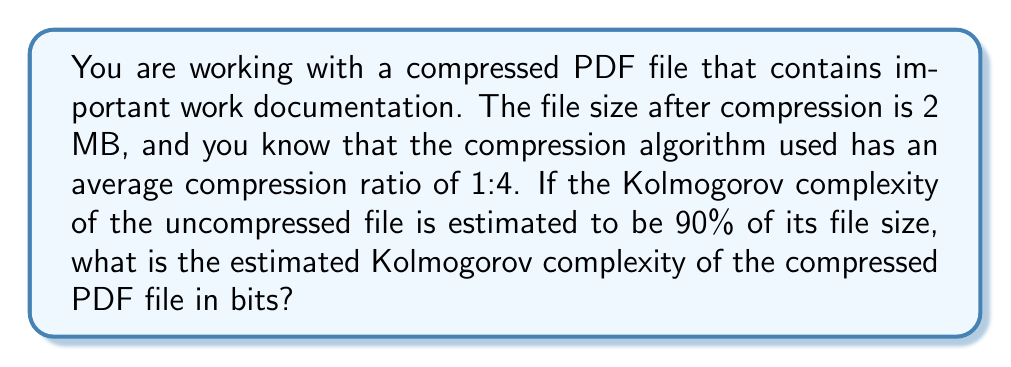Show me your answer to this math problem. To solve this problem, let's break it down into steps:

1. Calculate the original (uncompressed) file size:
   Compressed size = 2 MB = 2 * 1024 * 1024 = 2,097,152 bytes
   Compression ratio = 1:4
   Original size = 2,097,152 * 4 = 8,388,608 bytes

2. Convert the original file size to bits:
   $$8,388,608 \text{ bytes} * 8 \text{ bits/byte} = 67,108,864 \text{ bits}$$

3. Calculate the Kolmogorov complexity of the uncompressed file:
   Given: Kolmogorov complexity is 90% of the file size
   $$K(uncompressed) = 0.90 * 67,108,864 = 60,397,977.6 \text{ bits}$$

4. Estimate the Kolmogorov complexity of the compressed file:
   The Kolmogorov complexity of the compressed file cannot be significantly less than the Kolmogorov complexity of the uncompressed file, as compression algorithms are general-purpose and don't significantly reduce the information content.

   However, we need to account for the decompression algorithm. Let's assume the decompression algorithm can be described in about 1000 bits.

   $$K(compressed) \approx K(uncompressed) + K(decompression\_algorithm)$$
   $$K(compressed) \approx 60,397,977.6 + 1000 = 60,398,977.6 \text{ bits}$$

5. Round to the nearest whole number:
   $$K(compressed) \approx 60,398,978 \text{ bits}$$
Answer: The estimated Kolmogorov complexity of the compressed PDF file is approximately 60,398,978 bits. 